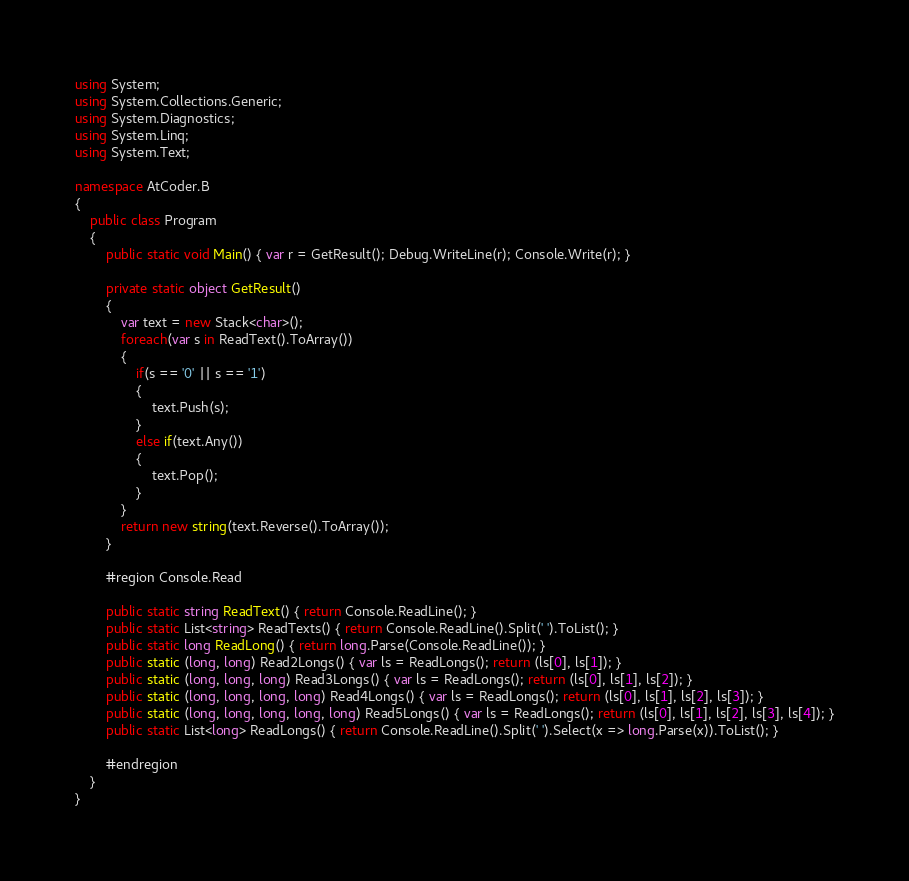<code> <loc_0><loc_0><loc_500><loc_500><_C#_>using System;
using System.Collections.Generic;
using System.Diagnostics;
using System.Linq;
using System.Text;

namespace AtCoder.B
{
    public class Program
    {
        public static void Main() { var r = GetResult(); Debug.WriteLine(r); Console.Write(r); }

        private static object GetResult()
        {
            var text = new Stack<char>();
            foreach(var s in ReadText().ToArray())
            {
                if(s == '0' || s == '1')
                {
                    text.Push(s);
                }
                else if(text.Any())
                {
                    text.Pop();
                }
            }
            return new string(text.Reverse().ToArray());
        }

        #region Console.Read

        public static string ReadText() { return Console.ReadLine(); }
        public static List<string> ReadTexts() { return Console.ReadLine().Split(' ').ToList(); }
        public static long ReadLong() { return long.Parse(Console.ReadLine()); }
        public static (long, long) Read2Longs() { var ls = ReadLongs(); return (ls[0], ls[1]); }
        public static (long, long, long) Read3Longs() { var ls = ReadLongs(); return (ls[0], ls[1], ls[2]); }
        public static (long, long, long, long) Read4Longs() { var ls = ReadLongs(); return (ls[0], ls[1], ls[2], ls[3]); }
        public static (long, long, long, long, long) Read5Longs() { var ls = ReadLongs(); return (ls[0], ls[1], ls[2], ls[3], ls[4]); }
        public static List<long> ReadLongs() { return Console.ReadLine().Split(' ').Select(x => long.Parse(x)).ToList(); }

        #endregion
    }
}
</code> 